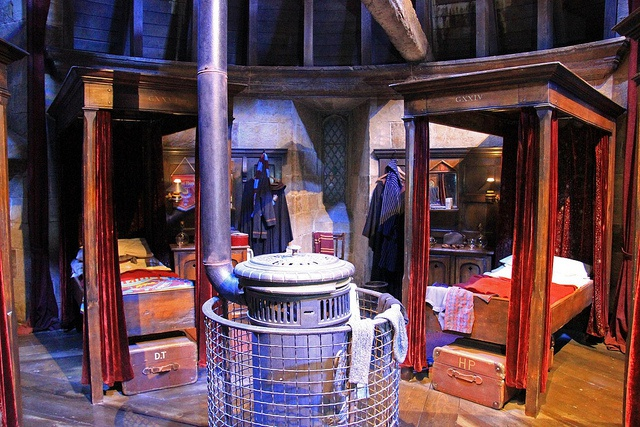Describe the objects in this image and their specific colors. I can see bed in blue, brown, white, red, and black tones, suitcase in blue, salmon, black, and brown tones, suitcase in blue, brown, purple, lightpink, and salmon tones, bed in blue, orange, brown, and lightgray tones, and chair in blue, purple, brown, and lightpink tones in this image. 